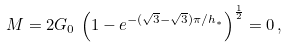<formula> <loc_0><loc_0><loc_500><loc_500>M = 2 G _ { 0 } \, \left ( 1 - e ^ { - ( \sqrt { 3 } - \sqrt { 3 } ) \pi / h _ { * } } \right ) ^ { \frac { 1 } { 2 } } = 0 \, ,</formula> 